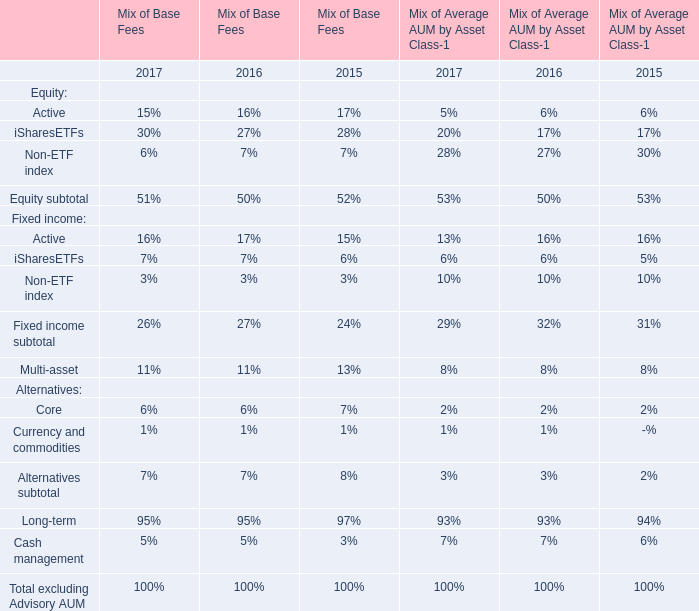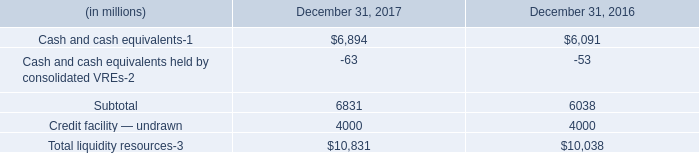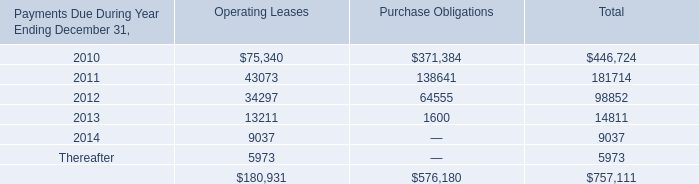what is the growth rate in the balance of total liquidity resources in 2017? 
Computations: ((10831 - 10038) / 10038)
Answer: 0.079. 